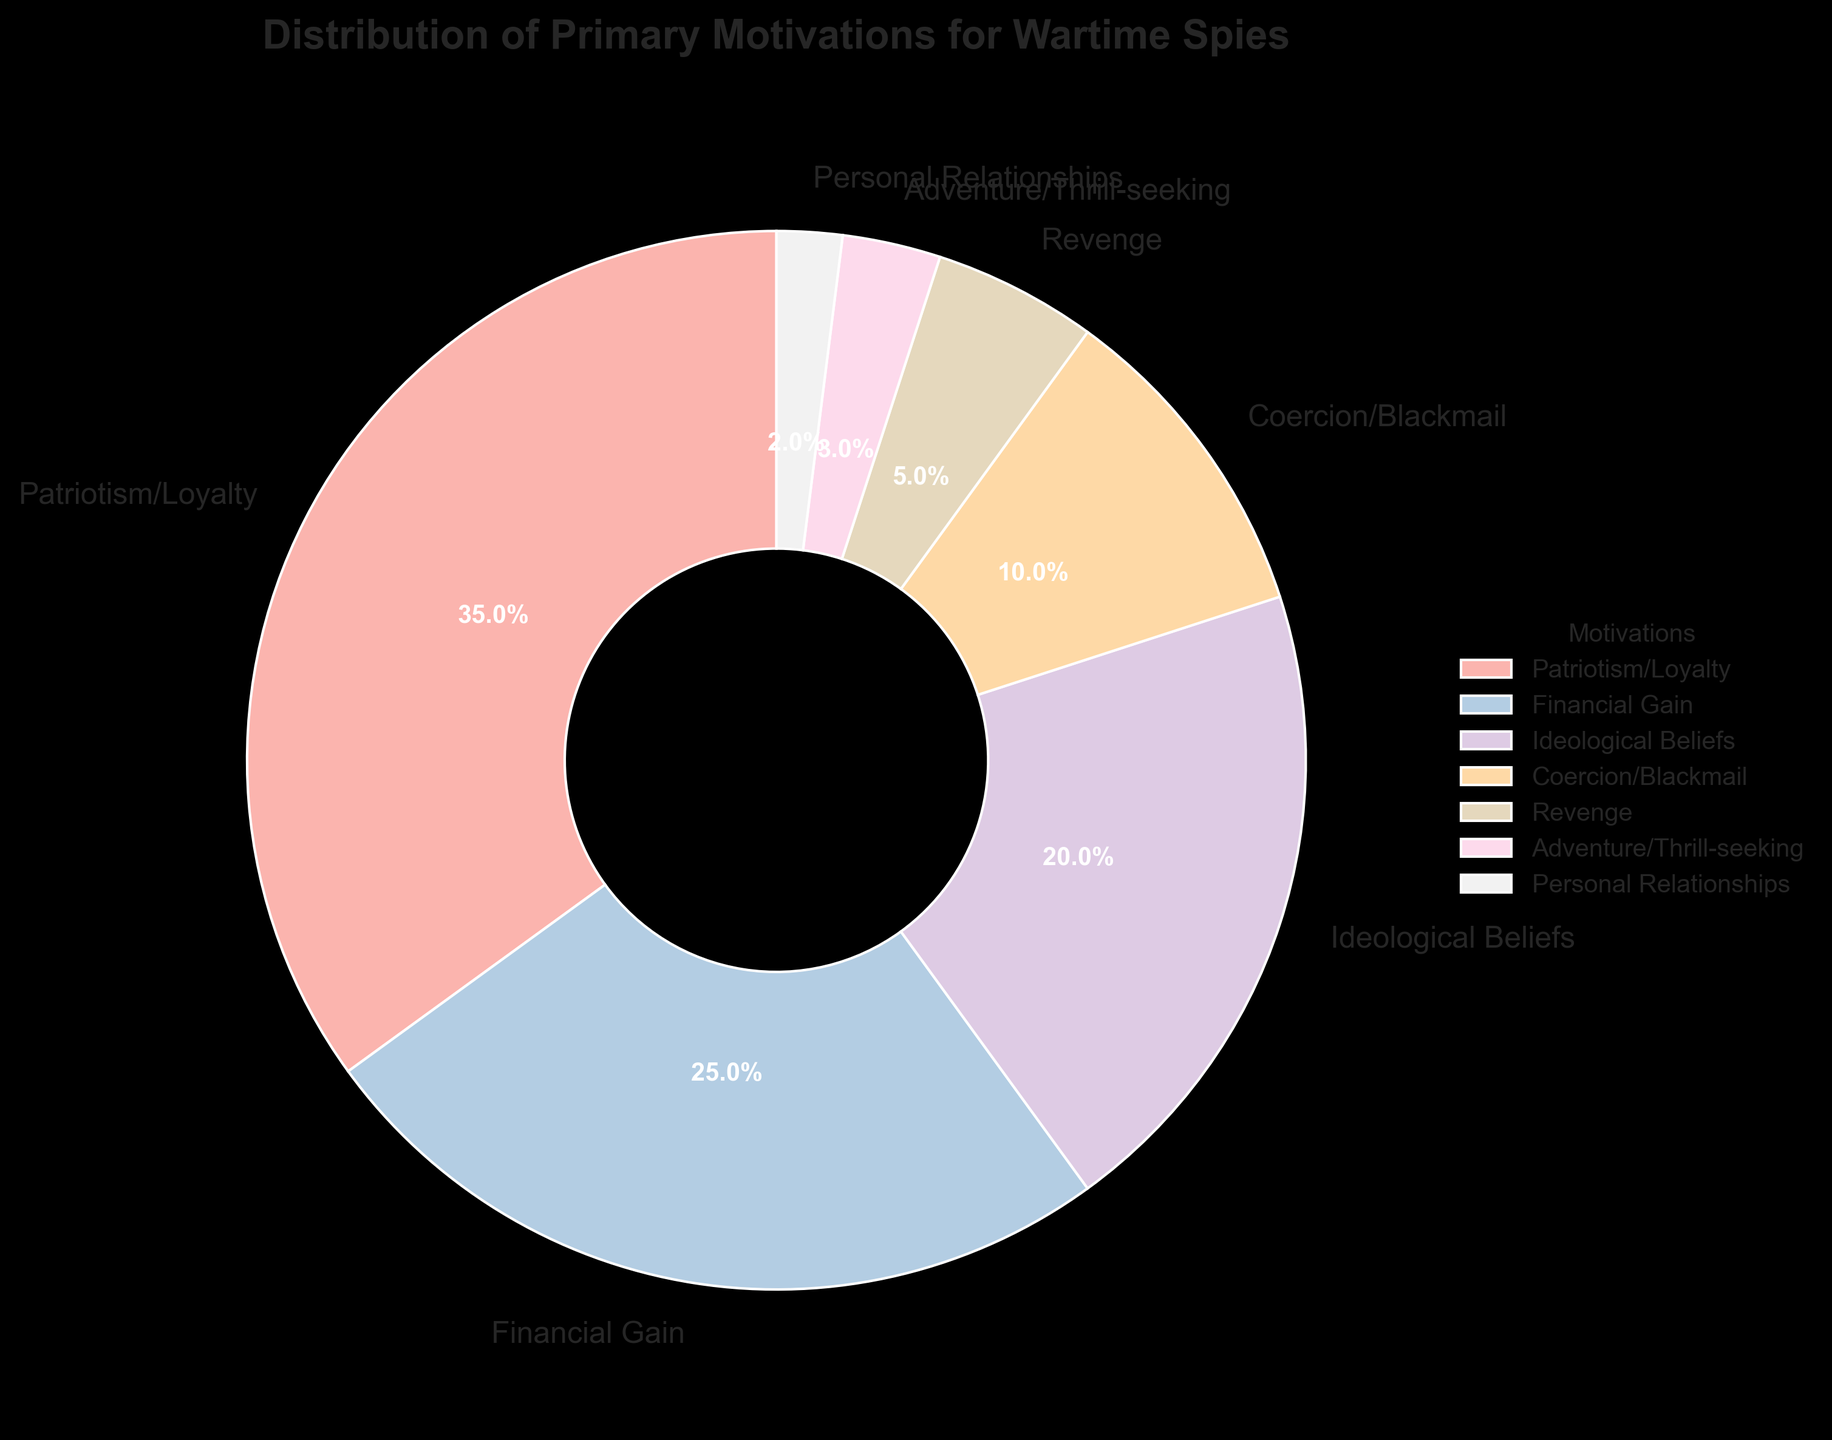What's the most common primary motivation for wartime spies? The largest segment of the pie chart represents "Patriotism/Loyalty" with 35%.
Answer: Patriotism/Loyalty Which motivation has the smallest percentage? The smallest segment of the pie chart represents "Personal Relationships" with 2%.
Answer: Personal Relationships How many times larger is the percentage of patriotism/loyalty compared to adventure/thrill-seeking? The percentage for Patriotism/Loyalty is 35%, and for Adventure/Thrill-seeking, it is 3%. Divide 35 by 3 to find the ratio: 35 / 3 ≈ 11.67.
Answer: Approximately 11.67 times larger What is the combined percentage of ideological beliefs and revenge? The percentage for Ideological Beliefs is 20%, and for Revenge, it is 5%. Add these together: 20% + 5% = 25%.
Answer: 25% Is the percentage for financial gain larger or smaller than the percentage for ideological beliefs? The percentage for Financial Gain is 25%, and for Ideological Beliefs, it is 20%. Since 25% is greater than 20%, Financial Gain is larger.
Answer: Larger What is the difference in percentage between the two least common motivations? The two least common motivations are Personal Relationships (2%) and Adventure/Thrill-seeking (3%). The difference is 3% - 2% = 1%.
Answer: 1% Which two motivations together make up less than 10%? Adventure/Thrill-seeking (3%) and Personal Relationships (2%) together make up 3% + 2% = 5%, which is less than 10%.
Answer: Adventure/Thrill-seeking and Personal Relationships What percentage of spies were motivated by something other than loyalty and financial gain? The total percentage for motivations aside from Patriotism/Loyalty (35%) and Financial Gain (25%) is calculated by subtracting these from 100%: 100% - 35% - 25% = 40%.
Answer: 40% Which color represents revenge on the pie chart? In the given code, colors are assigned using the Pastel1 palette. By observing the color corresponding to the "Revenge" label, the specific color can be identified visually from the chart.
Answer: It depends on the rendered pie chart (not specified in the data) Which motivations together account for exactly half of the total percentage? "Financial Gain" (25%) and "Ideological Beliefs" (20%) together sum up to 45%. By adding Adventure/Thrill-seeking (3%) and Personal Relationships (2%), this totals to 25% + 20% + 3% + 2% = 50%.
Answer: Financial Gain, Ideological Beliefs, Adventure/Thrill-seeking, Personal Relationships 